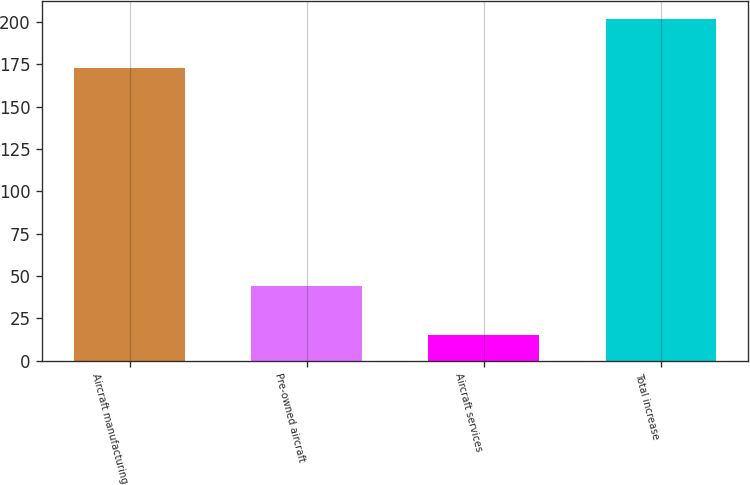Convert chart. <chart><loc_0><loc_0><loc_500><loc_500><bar_chart><fcel>Aircraft manufacturing<fcel>Pre-owned aircraft<fcel>Aircraft services<fcel>Total increase<nl><fcel>173<fcel>44<fcel>15<fcel>202<nl></chart> 